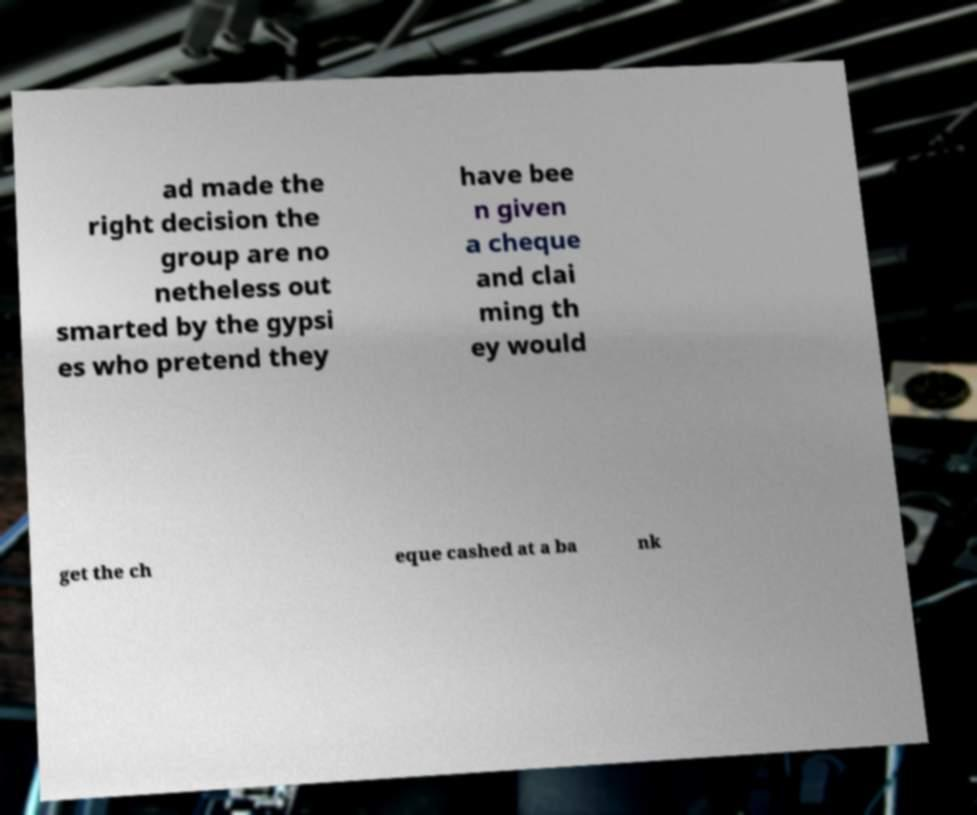Can you read and provide the text displayed in the image?This photo seems to have some interesting text. Can you extract and type it out for me? ad made the right decision the group are no netheless out smarted by the gypsi es who pretend they have bee n given a cheque and clai ming th ey would get the ch eque cashed at a ba nk 